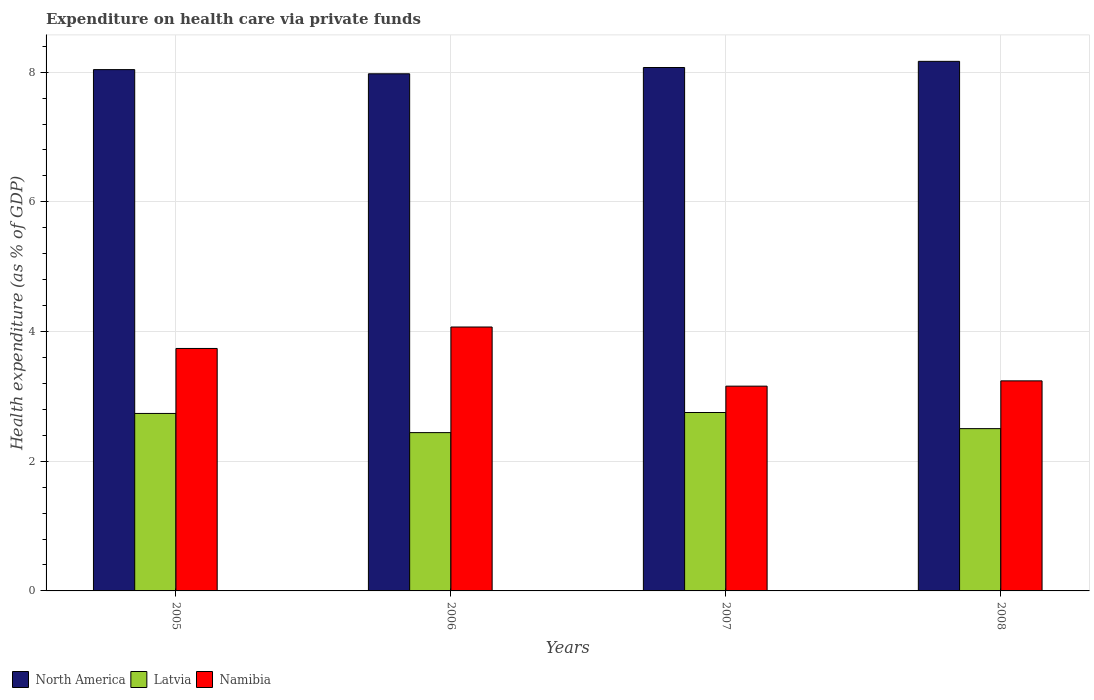How many different coloured bars are there?
Your answer should be compact. 3. How many groups of bars are there?
Provide a short and direct response. 4. Are the number of bars on each tick of the X-axis equal?
Your response must be concise. Yes. How many bars are there on the 2nd tick from the left?
Give a very brief answer. 3. What is the expenditure made on health care in Namibia in 2006?
Offer a terse response. 4.07. Across all years, what is the maximum expenditure made on health care in Namibia?
Provide a short and direct response. 4.07. Across all years, what is the minimum expenditure made on health care in Namibia?
Make the answer very short. 3.16. In which year was the expenditure made on health care in Namibia maximum?
Ensure brevity in your answer.  2006. In which year was the expenditure made on health care in North America minimum?
Your response must be concise. 2006. What is the total expenditure made on health care in North America in the graph?
Give a very brief answer. 32.25. What is the difference between the expenditure made on health care in Latvia in 2005 and that in 2008?
Make the answer very short. 0.23. What is the difference between the expenditure made on health care in Latvia in 2007 and the expenditure made on health care in Namibia in 2005?
Your response must be concise. -0.99. What is the average expenditure made on health care in Latvia per year?
Keep it short and to the point. 2.61. In the year 2008, what is the difference between the expenditure made on health care in North America and expenditure made on health care in Latvia?
Keep it short and to the point. 5.66. In how many years, is the expenditure made on health care in Namibia greater than 1.2000000000000002 %?
Offer a very short reply. 4. What is the ratio of the expenditure made on health care in North America in 2005 to that in 2008?
Make the answer very short. 0.98. What is the difference between the highest and the second highest expenditure made on health care in Namibia?
Ensure brevity in your answer.  0.33. What is the difference between the highest and the lowest expenditure made on health care in Namibia?
Make the answer very short. 0.91. Is the sum of the expenditure made on health care in Latvia in 2007 and 2008 greater than the maximum expenditure made on health care in North America across all years?
Offer a very short reply. No. What does the 1st bar from the right in 2007 represents?
Keep it short and to the point. Namibia. Is it the case that in every year, the sum of the expenditure made on health care in Namibia and expenditure made on health care in Latvia is greater than the expenditure made on health care in North America?
Give a very brief answer. No. Are all the bars in the graph horizontal?
Offer a terse response. No. What is the difference between two consecutive major ticks on the Y-axis?
Your answer should be compact. 2. Where does the legend appear in the graph?
Offer a very short reply. Bottom left. What is the title of the graph?
Your answer should be compact. Expenditure on health care via private funds. Does "Ireland" appear as one of the legend labels in the graph?
Ensure brevity in your answer.  No. What is the label or title of the Y-axis?
Your answer should be very brief. Health expenditure (as % of GDP). What is the Health expenditure (as % of GDP) of North America in 2005?
Provide a succinct answer. 8.04. What is the Health expenditure (as % of GDP) in Latvia in 2005?
Give a very brief answer. 2.74. What is the Health expenditure (as % of GDP) in Namibia in 2005?
Give a very brief answer. 3.74. What is the Health expenditure (as % of GDP) of North America in 2006?
Provide a succinct answer. 7.98. What is the Health expenditure (as % of GDP) in Latvia in 2006?
Your answer should be very brief. 2.44. What is the Health expenditure (as % of GDP) of Namibia in 2006?
Make the answer very short. 4.07. What is the Health expenditure (as % of GDP) in North America in 2007?
Offer a very short reply. 8.07. What is the Health expenditure (as % of GDP) in Latvia in 2007?
Ensure brevity in your answer.  2.75. What is the Health expenditure (as % of GDP) of Namibia in 2007?
Provide a short and direct response. 3.16. What is the Health expenditure (as % of GDP) in North America in 2008?
Offer a terse response. 8.17. What is the Health expenditure (as % of GDP) in Latvia in 2008?
Keep it short and to the point. 2.5. What is the Health expenditure (as % of GDP) in Namibia in 2008?
Your response must be concise. 3.24. Across all years, what is the maximum Health expenditure (as % of GDP) of North America?
Provide a short and direct response. 8.17. Across all years, what is the maximum Health expenditure (as % of GDP) in Latvia?
Give a very brief answer. 2.75. Across all years, what is the maximum Health expenditure (as % of GDP) in Namibia?
Keep it short and to the point. 4.07. Across all years, what is the minimum Health expenditure (as % of GDP) in North America?
Your answer should be very brief. 7.98. Across all years, what is the minimum Health expenditure (as % of GDP) of Latvia?
Offer a very short reply. 2.44. Across all years, what is the minimum Health expenditure (as % of GDP) of Namibia?
Your answer should be very brief. 3.16. What is the total Health expenditure (as % of GDP) in North America in the graph?
Offer a terse response. 32.25. What is the total Health expenditure (as % of GDP) in Latvia in the graph?
Offer a very short reply. 10.43. What is the total Health expenditure (as % of GDP) in Namibia in the graph?
Make the answer very short. 14.21. What is the difference between the Health expenditure (as % of GDP) of North America in 2005 and that in 2006?
Offer a very short reply. 0.06. What is the difference between the Health expenditure (as % of GDP) of Latvia in 2005 and that in 2006?
Your answer should be very brief. 0.3. What is the difference between the Health expenditure (as % of GDP) of Namibia in 2005 and that in 2006?
Offer a terse response. -0.33. What is the difference between the Health expenditure (as % of GDP) in North America in 2005 and that in 2007?
Your answer should be very brief. -0.03. What is the difference between the Health expenditure (as % of GDP) in Latvia in 2005 and that in 2007?
Ensure brevity in your answer.  -0.01. What is the difference between the Health expenditure (as % of GDP) in Namibia in 2005 and that in 2007?
Your response must be concise. 0.58. What is the difference between the Health expenditure (as % of GDP) of North America in 2005 and that in 2008?
Provide a short and direct response. -0.13. What is the difference between the Health expenditure (as % of GDP) of Latvia in 2005 and that in 2008?
Provide a short and direct response. 0.23. What is the difference between the Health expenditure (as % of GDP) of Namibia in 2005 and that in 2008?
Your answer should be very brief. 0.5. What is the difference between the Health expenditure (as % of GDP) in North America in 2006 and that in 2007?
Offer a very short reply. -0.1. What is the difference between the Health expenditure (as % of GDP) of Latvia in 2006 and that in 2007?
Your response must be concise. -0.31. What is the difference between the Health expenditure (as % of GDP) of Namibia in 2006 and that in 2007?
Ensure brevity in your answer.  0.91. What is the difference between the Health expenditure (as % of GDP) in North America in 2006 and that in 2008?
Your answer should be very brief. -0.19. What is the difference between the Health expenditure (as % of GDP) of Latvia in 2006 and that in 2008?
Keep it short and to the point. -0.06. What is the difference between the Health expenditure (as % of GDP) in Namibia in 2006 and that in 2008?
Provide a short and direct response. 0.83. What is the difference between the Health expenditure (as % of GDP) of North America in 2007 and that in 2008?
Your answer should be compact. -0.09. What is the difference between the Health expenditure (as % of GDP) in Latvia in 2007 and that in 2008?
Keep it short and to the point. 0.25. What is the difference between the Health expenditure (as % of GDP) in Namibia in 2007 and that in 2008?
Make the answer very short. -0.08. What is the difference between the Health expenditure (as % of GDP) of North America in 2005 and the Health expenditure (as % of GDP) of Latvia in 2006?
Your response must be concise. 5.6. What is the difference between the Health expenditure (as % of GDP) in North America in 2005 and the Health expenditure (as % of GDP) in Namibia in 2006?
Make the answer very short. 3.97. What is the difference between the Health expenditure (as % of GDP) of Latvia in 2005 and the Health expenditure (as % of GDP) of Namibia in 2006?
Give a very brief answer. -1.33. What is the difference between the Health expenditure (as % of GDP) of North America in 2005 and the Health expenditure (as % of GDP) of Latvia in 2007?
Your response must be concise. 5.29. What is the difference between the Health expenditure (as % of GDP) of North America in 2005 and the Health expenditure (as % of GDP) of Namibia in 2007?
Offer a terse response. 4.88. What is the difference between the Health expenditure (as % of GDP) of Latvia in 2005 and the Health expenditure (as % of GDP) of Namibia in 2007?
Ensure brevity in your answer.  -0.42. What is the difference between the Health expenditure (as % of GDP) of North America in 2005 and the Health expenditure (as % of GDP) of Latvia in 2008?
Ensure brevity in your answer.  5.54. What is the difference between the Health expenditure (as % of GDP) in North America in 2005 and the Health expenditure (as % of GDP) in Namibia in 2008?
Your answer should be compact. 4.8. What is the difference between the Health expenditure (as % of GDP) in Latvia in 2005 and the Health expenditure (as % of GDP) in Namibia in 2008?
Your response must be concise. -0.5. What is the difference between the Health expenditure (as % of GDP) in North America in 2006 and the Health expenditure (as % of GDP) in Latvia in 2007?
Your answer should be compact. 5.22. What is the difference between the Health expenditure (as % of GDP) in North America in 2006 and the Health expenditure (as % of GDP) in Namibia in 2007?
Offer a very short reply. 4.82. What is the difference between the Health expenditure (as % of GDP) in Latvia in 2006 and the Health expenditure (as % of GDP) in Namibia in 2007?
Your answer should be compact. -0.72. What is the difference between the Health expenditure (as % of GDP) of North America in 2006 and the Health expenditure (as % of GDP) of Latvia in 2008?
Provide a succinct answer. 5.47. What is the difference between the Health expenditure (as % of GDP) of North America in 2006 and the Health expenditure (as % of GDP) of Namibia in 2008?
Your response must be concise. 4.74. What is the difference between the Health expenditure (as % of GDP) in Latvia in 2006 and the Health expenditure (as % of GDP) in Namibia in 2008?
Keep it short and to the point. -0.8. What is the difference between the Health expenditure (as % of GDP) of North America in 2007 and the Health expenditure (as % of GDP) of Latvia in 2008?
Provide a succinct answer. 5.57. What is the difference between the Health expenditure (as % of GDP) in North America in 2007 and the Health expenditure (as % of GDP) in Namibia in 2008?
Make the answer very short. 4.83. What is the difference between the Health expenditure (as % of GDP) in Latvia in 2007 and the Health expenditure (as % of GDP) in Namibia in 2008?
Offer a very short reply. -0.49. What is the average Health expenditure (as % of GDP) of North America per year?
Keep it short and to the point. 8.06. What is the average Health expenditure (as % of GDP) in Latvia per year?
Offer a terse response. 2.61. What is the average Health expenditure (as % of GDP) in Namibia per year?
Provide a short and direct response. 3.55. In the year 2005, what is the difference between the Health expenditure (as % of GDP) in North America and Health expenditure (as % of GDP) in Latvia?
Offer a very short reply. 5.3. In the year 2005, what is the difference between the Health expenditure (as % of GDP) in North America and Health expenditure (as % of GDP) in Namibia?
Ensure brevity in your answer.  4.3. In the year 2005, what is the difference between the Health expenditure (as % of GDP) of Latvia and Health expenditure (as % of GDP) of Namibia?
Make the answer very short. -1. In the year 2006, what is the difference between the Health expenditure (as % of GDP) in North America and Health expenditure (as % of GDP) in Latvia?
Keep it short and to the point. 5.53. In the year 2006, what is the difference between the Health expenditure (as % of GDP) of North America and Health expenditure (as % of GDP) of Namibia?
Offer a terse response. 3.9. In the year 2006, what is the difference between the Health expenditure (as % of GDP) of Latvia and Health expenditure (as % of GDP) of Namibia?
Keep it short and to the point. -1.63. In the year 2007, what is the difference between the Health expenditure (as % of GDP) of North America and Health expenditure (as % of GDP) of Latvia?
Provide a short and direct response. 5.32. In the year 2007, what is the difference between the Health expenditure (as % of GDP) of North America and Health expenditure (as % of GDP) of Namibia?
Offer a terse response. 4.91. In the year 2007, what is the difference between the Health expenditure (as % of GDP) in Latvia and Health expenditure (as % of GDP) in Namibia?
Make the answer very short. -0.41. In the year 2008, what is the difference between the Health expenditure (as % of GDP) of North America and Health expenditure (as % of GDP) of Latvia?
Your response must be concise. 5.66. In the year 2008, what is the difference between the Health expenditure (as % of GDP) in North America and Health expenditure (as % of GDP) in Namibia?
Offer a terse response. 4.93. In the year 2008, what is the difference between the Health expenditure (as % of GDP) of Latvia and Health expenditure (as % of GDP) of Namibia?
Your answer should be compact. -0.74. What is the ratio of the Health expenditure (as % of GDP) of Latvia in 2005 to that in 2006?
Offer a terse response. 1.12. What is the ratio of the Health expenditure (as % of GDP) of Namibia in 2005 to that in 2006?
Keep it short and to the point. 0.92. What is the ratio of the Health expenditure (as % of GDP) of Namibia in 2005 to that in 2007?
Make the answer very short. 1.18. What is the ratio of the Health expenditure (as % of GDP) of North America in 2005 to that in 2008?
Your answer should be very brief. 0.98. What is the ratio of the Health expenditure (as % of GDP) of Latvia in 2005 to that in 2008?
Your answer should be compact. 1.09. What is the ratio of the Health expenditure (as % of GDP) of Namibia in 2005 to that in 2008?
Make the answer very short. 1.15. What is the ratio of the Health expenditure (as % of GDP) of Latvia in 2006 to that in 2007?
Your response must be concise. 0.89. What is the ratio of the Health expenditure (as % of GDP) of Namibia in 2006 to that in 2007?
Offer a very short reply. 1.29. What is the ratio of the Health expenditure (as % of GDP) in North America in 2006 to that in 2008?
Ensure brevity in your answer.  0.98. What is the ratio of the Health expenditure (as % of GDP) of Latvia in 2006 to that in 2008?
Ensure brevity in your answer.  0.98. What is the ratio of the Health expenditure (as % of GDP) in Namibia in 2006 to that in 2008?
Give a very brief answer. 1.26. What is the ratio of the Health expenditure (as % of GDP) of North America in 2007 to that in 2008?
Your answer should be very brief. 0.99. What is the ratio of the Health expenditure (as % of GDP) of Latvia in 2007 to that in 2008?
Offer a very short reply. 1.1. What is the ratio of the Health expenditure (as % of GDP) in Namibia in 2007 to that in 2008?
Provide a short and direct response. 0.97. What is the difference between the highest and the second highest Health expenditure (as % of GDP) of North America?
Give a very brief answer. 0.09. What is the difference between the highest and the second highest Health expenditure (as % of GDP) of Latvia?
Offer a very short reply. 0.01. What is the difference between the highest and the second highest Health expenditure (as % of GDP) of Namibia?
Ensure brevity in your answer.  0.33. What is the difference between the highest and the lowest Health expenditure (as % of GDP) of North America?
Your answer should be very brief. 0.19. What is the difference between the highest and the lowest Health expenditure (as % of GDP) of Latvia?
Make the answer very short. 0.31. What is the difference between the highest and the lowest Health expenditure (as % of GDP) of Namibia?
Your answer should be compact. 0.91. 